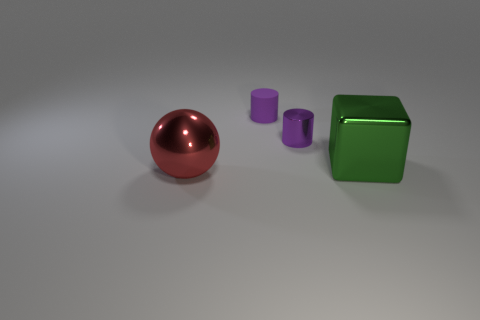Add 4 big blocks. How many objects exist? 8 Subtract all balls. How many objects are left? 3 Subtract all matte objects. Subtract all purple cylinders. How many objects are left? 1 Add 2 big green metallic things. How many big green metallic things are left? 3 Add 3 purple shiny cylinders. How many purple shiny cylinders exist? 4 Subtract 0 purple balls. How many objects are left? 4 